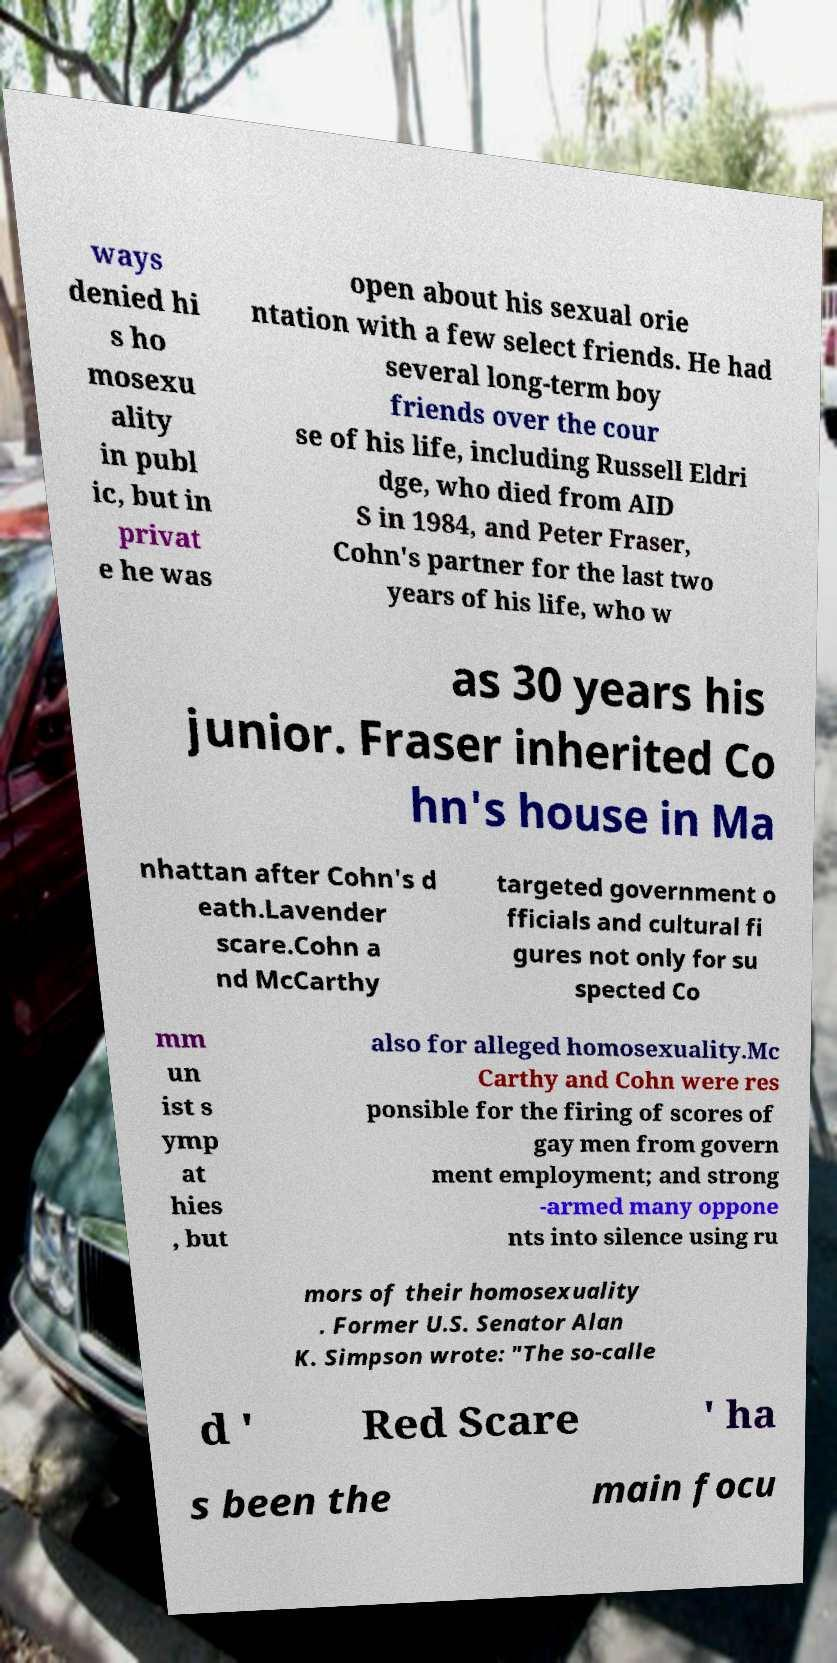Please identify and transcribe the text found in this image. ways denied hi s ho mosexu ality in publ ic, but in privat e he was open about his sexual orie ntation with a few select friends. He had several long-term boy friends over the cour se of his life, including Russell Eldri dge, who died from AID S in 1984, and Peter Fraser, Cohn's partner for the last two years of his life, who w as 30 years his junior. Fraser inherited Co hn's house in Ma nhattan after Cohn's d eath.Lavender scare.Cohn a nd McCarthy targeted government o fficials and cultural fi gures not only for su spected Co mm un ist s ymp at hies , but also for alleged homosexuality.Mc Carthy and Cohn were res ponsible for the firing of scores of gay men from govern ment employment; and strong -armed many oppone nts into silence using ru mors of their homosexuality . Former U.S. Senator Alan K. Simpson wrote: "The so-calle d ' Red Scare ' ha s been the main focu 